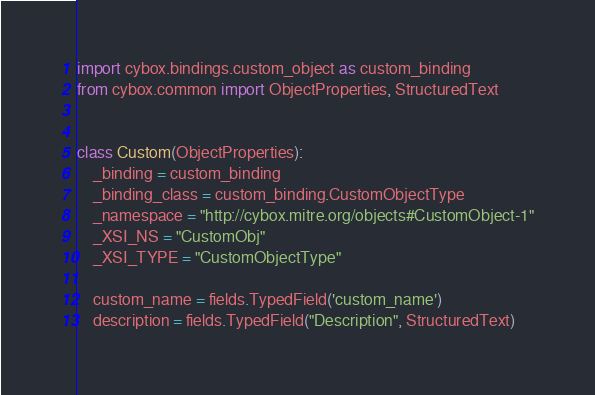Convert code to text. <code><loc_0><loc_0><loc_500><loc_500><_Python_>
import cybox.bindings.custom_object as custom_binding
from cybox.common import ObjectProperties, StructuredText


class Custom(ObjectProperties):
    _binding = custom_binding
    _binding_class = custom_binding.CustomObjectType
    _namespace = "http://cybox.mitre.org/objects#CustomObject-1"
    _XSI_NS = "CustomObj"
    _XSI_TYPE = "CustomObjectType"

    custom_name = fields.TypedField('custom_name')
    description = fields.TypedField("Description", StructuredText)
</code> 